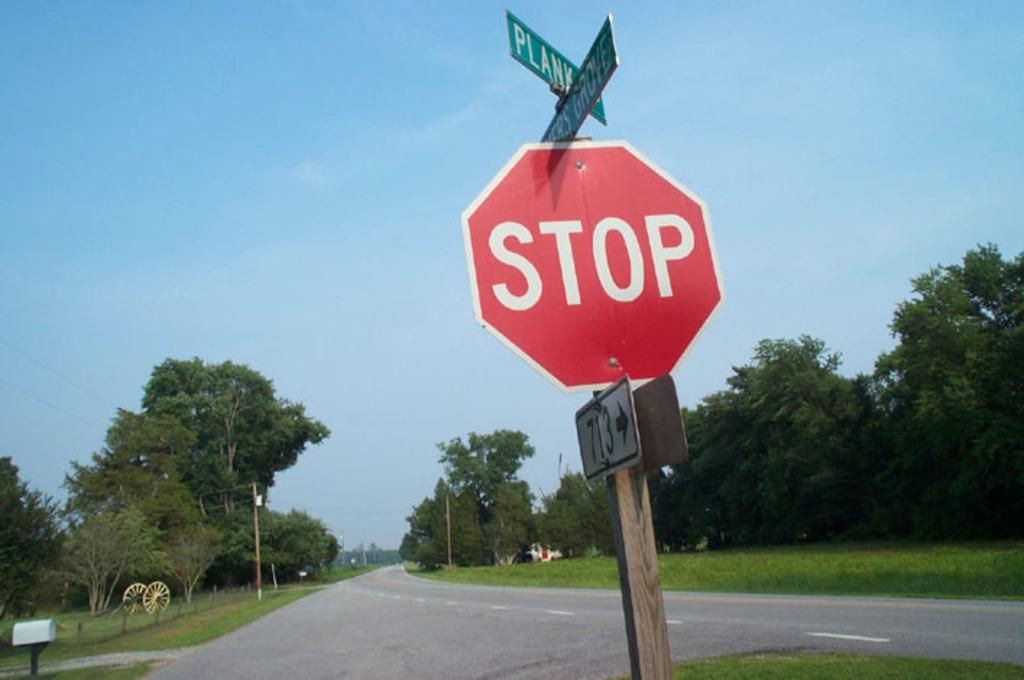<image>
Give a short and clear explanation of the subsequent image. A red stop sign on an open road with trees in the background. 